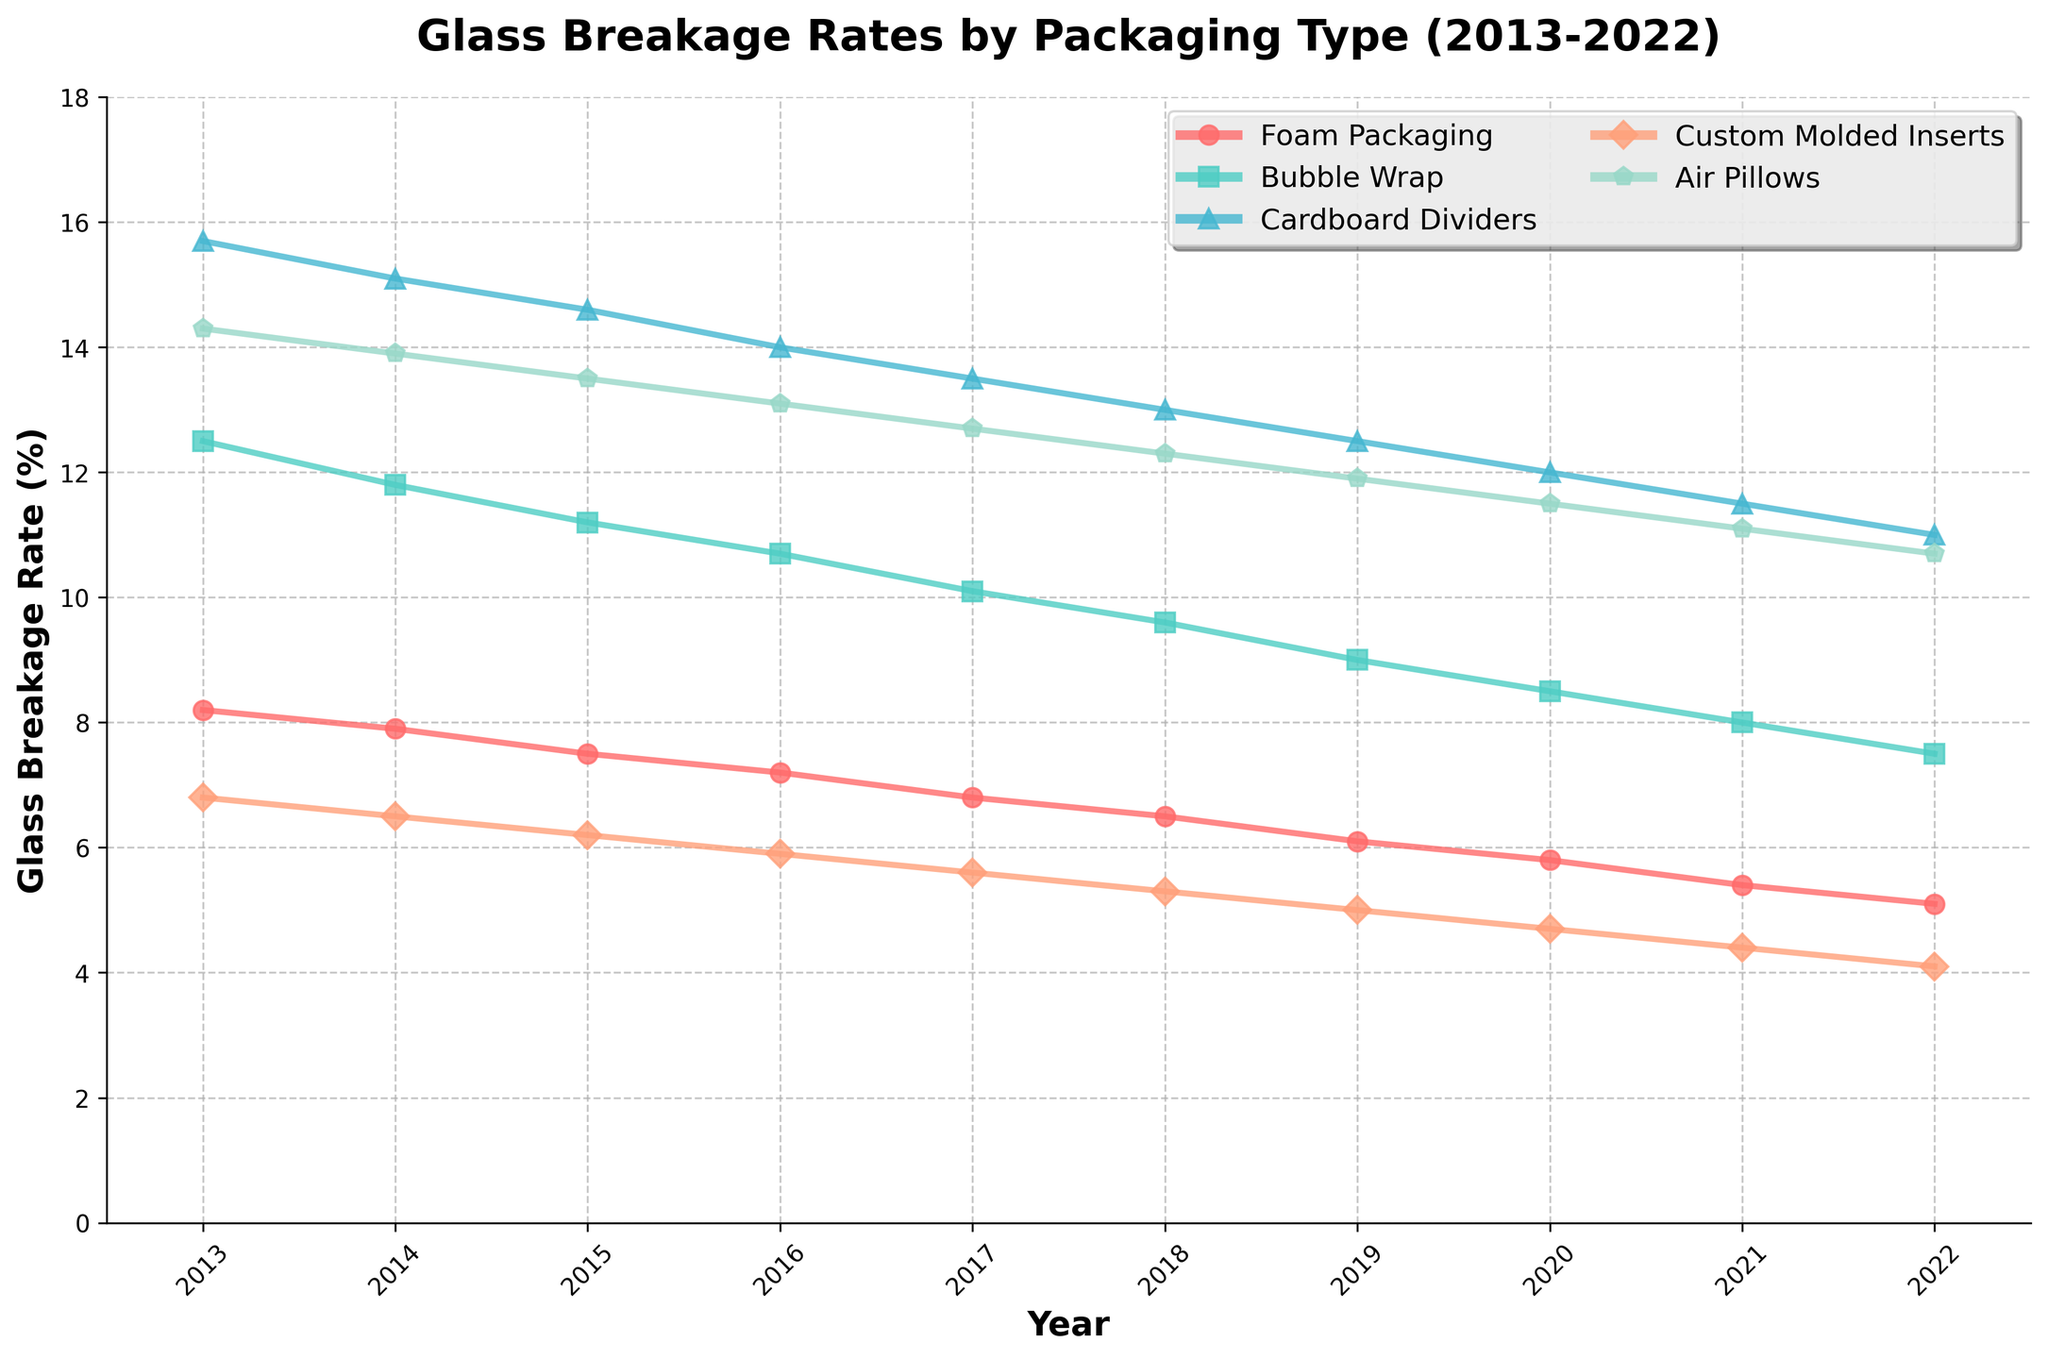How has the glass breakage rate for Bubble Wrap changed from 2013 to 2022? First, look at the line for Bubble Wrap over the years. In 2013, the rate is 12.5%, and in 2022, it has decreased to 7.5%.
Answer: It has decreased Which packaging type had the lowest breakage rate in 2017? Find the year 2017 on the x-axis and identify the packaging type with the lowest point on the y-axis. Custom Molded Inserts show the lowest rate at 5.6%.
Answer: Custom Molded Inserts What’s the general trend of glass breakage rates for Foam Packaging from 2013 to 2022? Observe the line for Foam Packaging. It consistently drops each year from 8.2% (2013) to 5.1% (2022).
Answer: The trend is decreasing In which year did Air Pillows experience the biggest drop in breakage rate compared to the previous year? Look at the line for Air Pillows and identify the biggest year-on-year vertical drop. From 2021 to 2022, the rate dropped from 11.1% to 10.7%.
Answer: 2022 compared to 2021 Compare the breakage rates of Custom Molded Inserts and Cardboard Dividers in 2020. Which one is lower? Find the year 2020 on the x-axis for both Custom Molded Inserts and Cardboard Dividers. The rates are 4.7% and 12.0%, respectively.
Answer: Custom Molded Inserts What is the average breakage rate of Cardboard Dividers over the decade? Sum up the yearly rates from 2013 to 2022: 15.7 + 15.1 + 14.6 + 14.0 + 13.5 + 13.0 + 12.5 + 12.0 + 11.5 + 11.0 = 132.9. Divide by 10 years.
Answer: 13.29% Which packaging type showed the most significant improvement in reducing breakage rates from 2013 to 2022? For each packaging type, subtract the 2022 rate from the 2013 rate and identify the highest difference. Custom Molded Inserts dropped from 6.8% to 4.1%, a change of 2.7%. However, Bubble Wrap dropped from 12.5% to 7.5%, which is a difference of 5.0%. Air Pillows dropped from 14.3% to 10.7%, a difference of 3.6%.
Answer: Bubble Wrap By how much did the breakage rate for Air Pillows decrease overall from 2013 to 2022? Subtract the 2022 rate from the 2013 rate for Air Pillows: 14.3 - 10.7 = 3.6%.
Answer: 3.6% Which two years have the same breakage rate for Foam Packaging? Observe the line for Foam Packaging and look for two years with the same y-axis value. Unfortunately, no two years have the exact same rate for Foam Packaging.
Answer: None Which year saw the largest year-on-year reduction in breakage rate for Bubble Wrap? Calculate the year-on-year differences for Bubble Wrap and find the largest one. From 2013 to 2014, the rate reduced by 0.7%.
Answer: 2013 to 2014 